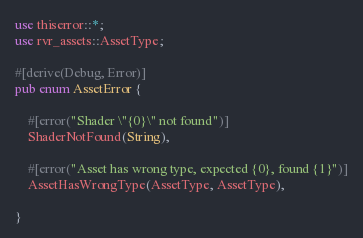Convert code to text. <code><loc_0><loc_0><loc_500><loc_500><_Rust_>use thiserror::*;
use rvr_assets::AssetType;

#[derive(Debug, Error)]
pub enum AssetError {

    #[error("Shader \"{0}\" not found")]
    ShaderNotFound(String),

    #[error("Asset has wrong type, expected {0}, found {1}")]
    AssetHasWrongType(AssetType, AssetType),
    
}
</code> 